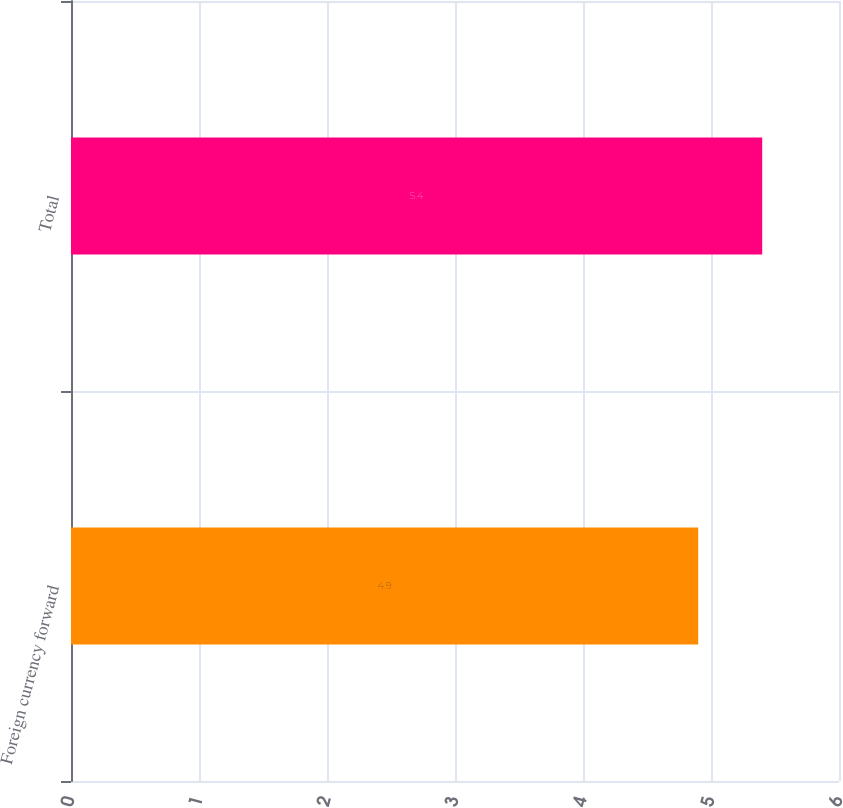Convert chart. <chart><loc_0><loc_0><loc_500><loc_500><bar_chart><fcel>Foreign currency forward<fcel>Total<nl><fcel>4.9<fcel>5.4<nl></chart> 